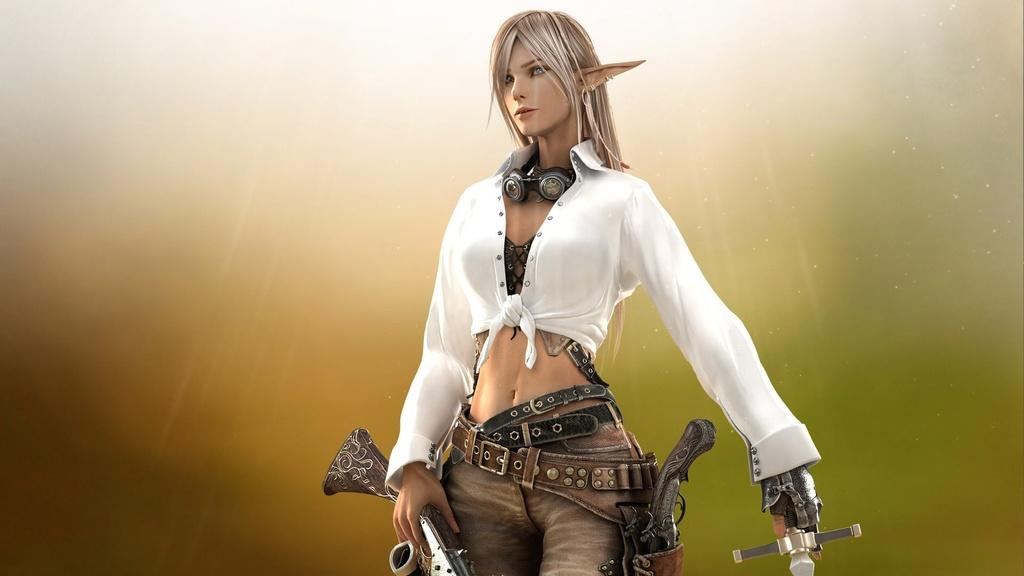What is the main subject of the image? There is a person depicted in the image. What is the person holding in the image? The person is holding a gun and a sword. What type of toothpaste is the person using in the image? There is no toothpaste present in the image. What is the person discussing with someone else in the image? The image does not show the person engaged in a discussion with anyone else. 